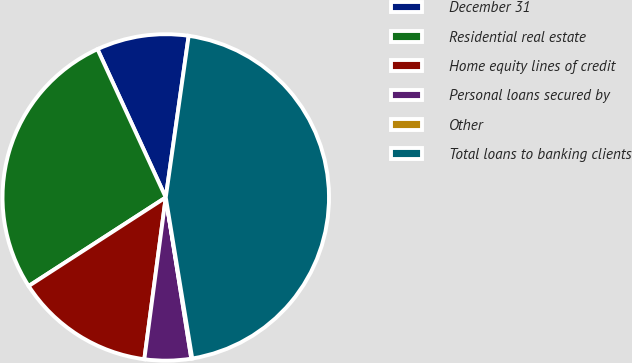<chart> <loc_0><loc_0><loc_500><loc_500><pie_chart><fcel>December 31<fcel>Residential real estate<fcel>Home equity lines of credit<fcel>Personal loans secured by<fcel>Other<fcel>Total loans to banking clients<nl><fcel>9.11%<fcel>27.26%<fcel>13.77%<fcel>4.6%<fcel>0.09%<fcel>45.16%<nl></chart> 